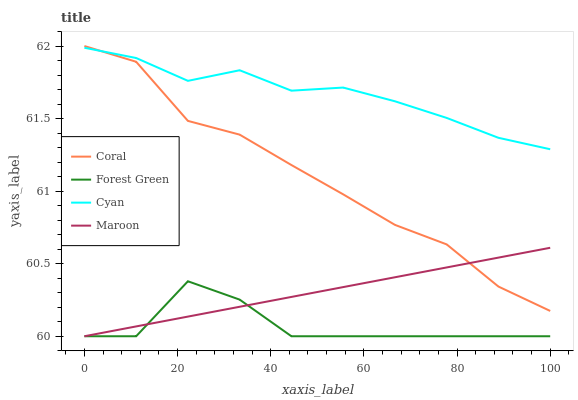Does Forest Green have the minimum area under the curve?
Answer yes or no. Yes. Does Cyan have the maximum area under the curve?
Answer yes or no. Yes. Does Coral have the minimum area under the curve?
Answer yes or no. No. Does Coral have the maximum area under the curve?
Answer yes or no. No. Is Maroon the smoothest?
Answer yes or no. Yes. Is Forest Green the roughest?
Answer yes or no. Yes. Is Coral the smoothest?
Answer yes or no. No. Is Coral the roughest?
Answer yes or no. No. Does Forest Green have the lowest value?
Answer yes or no. Yes. Does Coral have the lowest value?
Answer yes or no. No. Does Coral have the highest value?
Answer yes or no. Yes. Does Forest Green have the highest value?
Answer yes or no. No. Is Forest Green less than Cyan?
Answer yes or no. Yes. Is Cyan greater than Forest Green?
Answer yes or no. Yes. Does Coral intersect Maroon?
Answer yes or no. Yes. Is Coral less than Maroon?
Answer yes or no. No. Is Coral greater than Maroon?
Answer yes or no. No. Does Forest Green intersect Cyan?
Answer yes or no. No. 